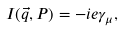Convert formula to latex. <formula><loc_0><loc_0><loc_500><loc_500>I ( { \vec { q } } , P ) = - i e \gamma _ { \mu } ,</formula> 